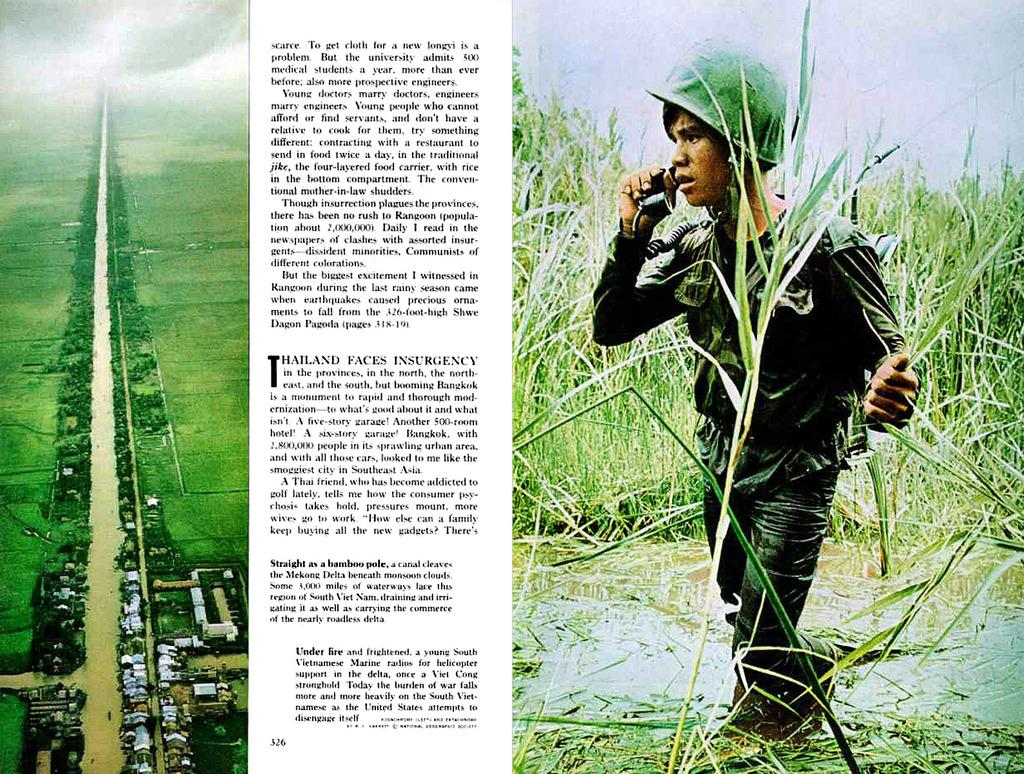What is depicted on the poster in the image? The poster features a person holding a telephone. What is the person on the poster wearing? The person on the poster is wearing a helmet. What type of vegetation can be seen in the image? There is grass visible in the image. What else can be seen in the image besides the poster? There are vehicles in the image. What type of soup is being served in the image? There is no soup present in the image. How many toes can be seen on the person in the image? There is no person visible in the image, only a poster featuring a person. 